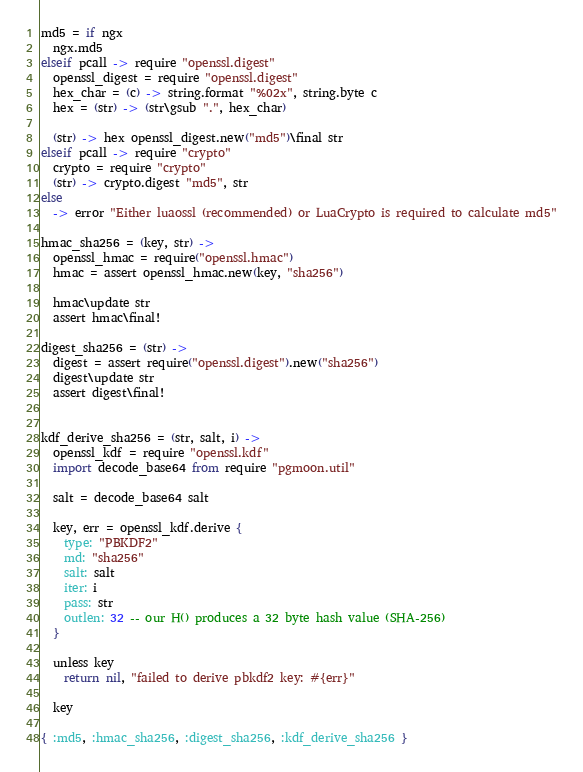Convert code to text. <code><loc_0><loc_0><loc_500><loc_500><_MoonScript_>
md5 = if ngx
  ngx.md5
elseif pcall -> require "openssl.digest"
  openssl_digest = require "openssl.digest"
  hex_char = (c) -> string.format "%02x", string.byte c
  hex = (str) -> (str\gsub ".", hex_char)

  (str) -> hex openssl_digest.new("md5")\final str
elseif pcall -> require "crypto"
  crypto = require "crypto"
  (str) -> crypto.digest "md5", str
else
  -> error "Either luaossl (recommended) or LuaCrypto is required to calculate md5"

hmac_sha256 = (key, str) ->
  openssl_hmac = require("openssl.hmac")
  hmac = assert openssl_hmac.new(key, "sha256")

  hmac\update str
  assert hmac\final!

digest_sha256 = (str) ->
  digest = assert require("openssl.digest").new("sha256")
  digest\update str
  assert digest\final!


kdf_derive_sha256 = (str, salt, i) ->
  openssl_kdf = require "openssl.kdf"
  import decode_base64 from require "pgmoon.util"

  salt = decode_base64 salt

  key, err = openssl_kdf.derive {
    type: "PBKDF2"
    md: "sha256"
    salt: salt
    iter: i
    pass: str
    outlen: 32 -- our H() produces a 32 byte hash value (SHA-256)
  }

  unless key
    return nil, "failed to derive pbkdf2 key: #{err}"

  key

{ :md5, :hmac_sha256, :digest_sha256, :kdf_derive_sha256 }
</code> 